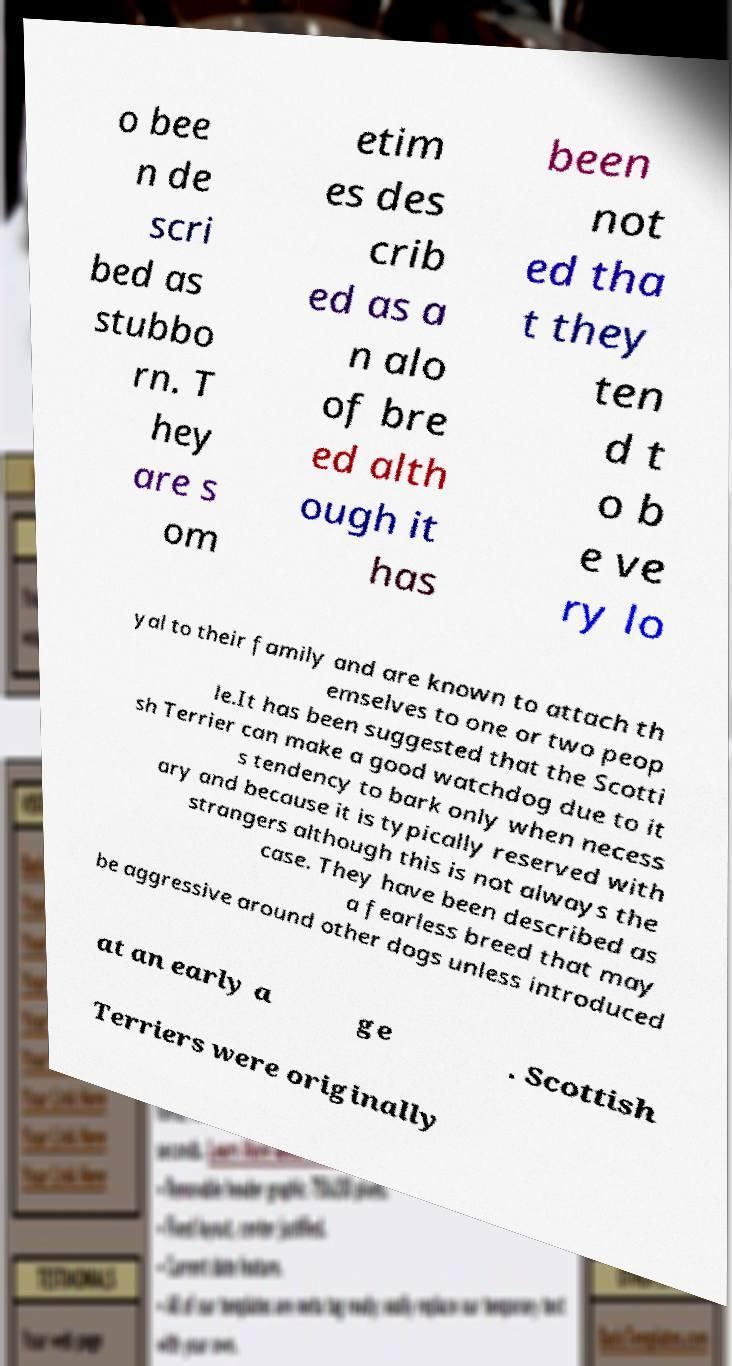For documentation purposes, I need the text within this image transcribed. Could you provide that? o bee n de scri bed as stubbo rn. T hey are s om etim es des crib ed as a n alo of bre ed alth ough it has been not ed tha t they ten d t o b e ve ry lo yal to their family and are known to attach th emselves to one or two peop le.It has been suggested that the Scotti sh Terrier can make a good watchdog due to it s tendency to bark only when necess ary and because it is typically reserved with strangers although this is not always the case. They have been described as a fearless breed that may be aggressive around other dogs unless introduced at an early a ge . Scottish Terriers were originally 